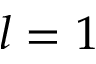<formula> <loc_0><loc_0><loc_500><loc_500>l = 1</formula> 